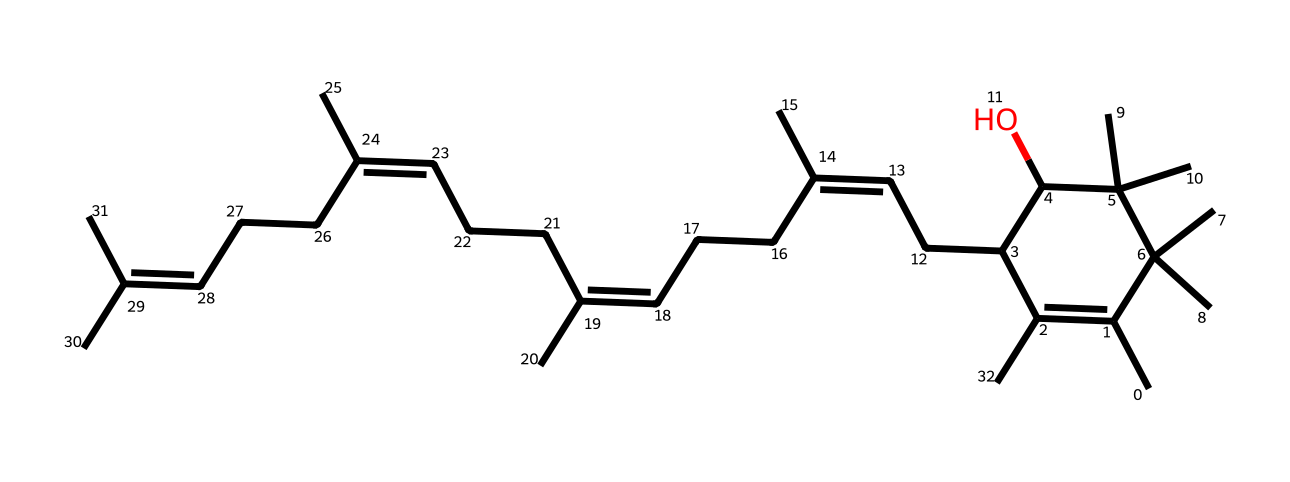What is the main functional group present in this vitamin? The structural formula of this vitamin shows multiple hydroxyl (-OH) groups, which are indicative of alcohols and are responsible for its solubility and reactivity in biological systems.
Answer: hydroxyl How many carbon atoms are in this vitamin? By examining the SMILES representation, we can count the number of carbon atoms depicted, which includes all branches and cycles outlined. There are 29 carbon atoms in total.
Answer: 29 What type of vitamin is represented by this structure? This chemical structure corresponds specifically to Vitamin E, known for its antioxidant properties and presence in skincare products for protection against UV damage.
Answer: Vitamin E How many double bonds are present in the carbon chain of this vitamin? The SMILES notation illustrates multiple instances of double bonds in the carbon chain, and by identifying them, we find there are 4 double bonds in total.
Answer: 4 Does this vitamin contain any rings in its structure? The chemical structure indicates a cyclic arrangement of atoms, particularly a six-membered carbon ring, as can be seen from the representation of the structure.
Answer: yes What is the primary role of Vitamin E in sunscreen products? Vitamin E acts as an antioxidant, helping to protect skin cells from damage caused by ultraviolet (UV) light and is often included in formulations to enhance skin health.
Answer: antioxidant 